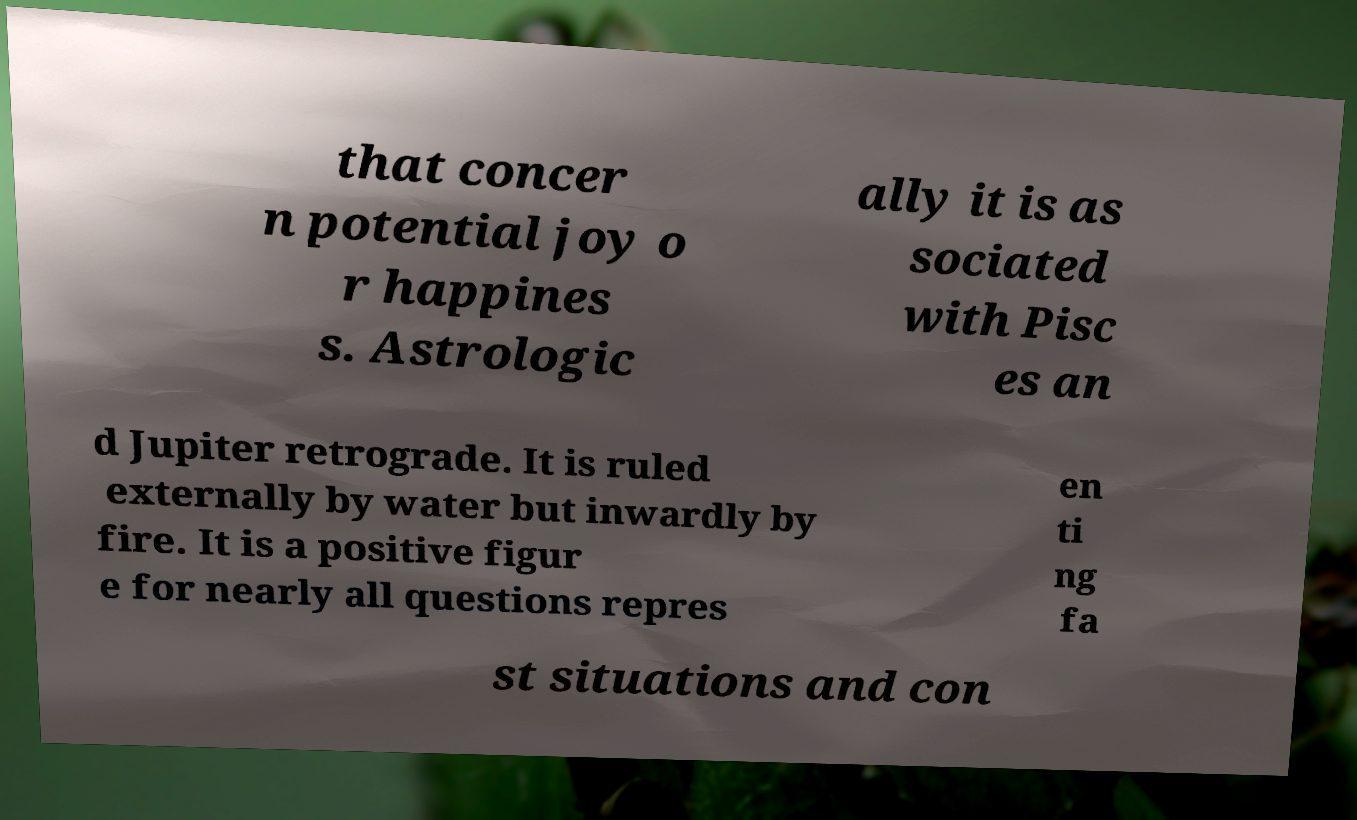Please read and relay the text visible in this image. What does it say? that concer n potential joy o r happines s. Astrologic ally it is as sociated with Pisc es an d Jupiter retrograde. It is ruled externally by water but inwardly by fire. It is a positive figur e for nearly all questions repres en ti ng fa st situations and con 